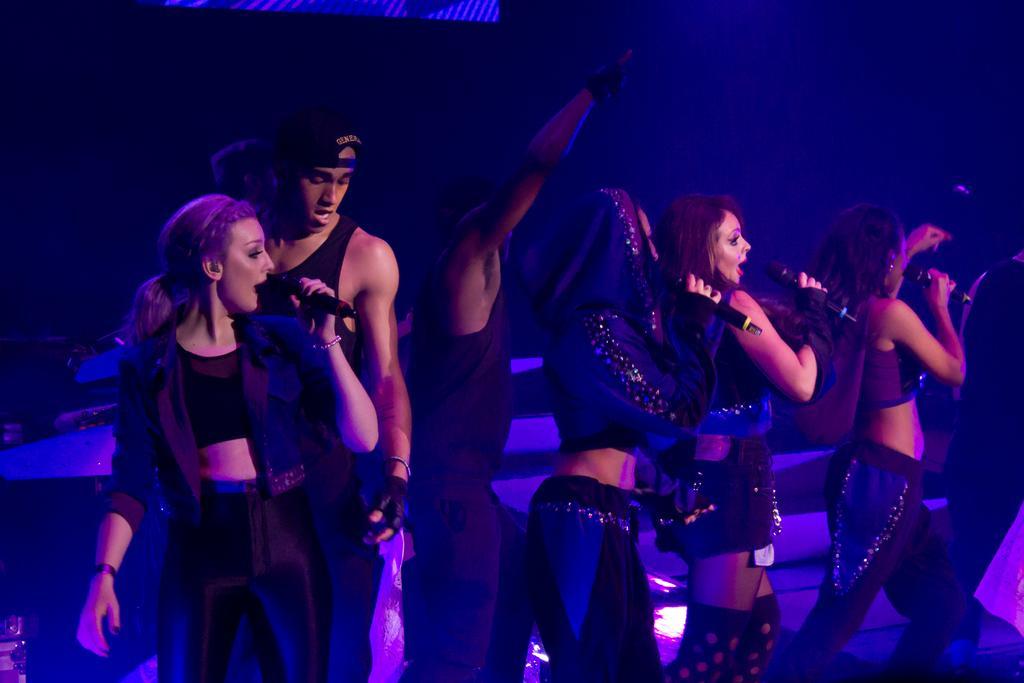How would you summarize this image in a sentence or two? In this image we can see there are a few people standing on the stage and they are holding mikes and singing. 